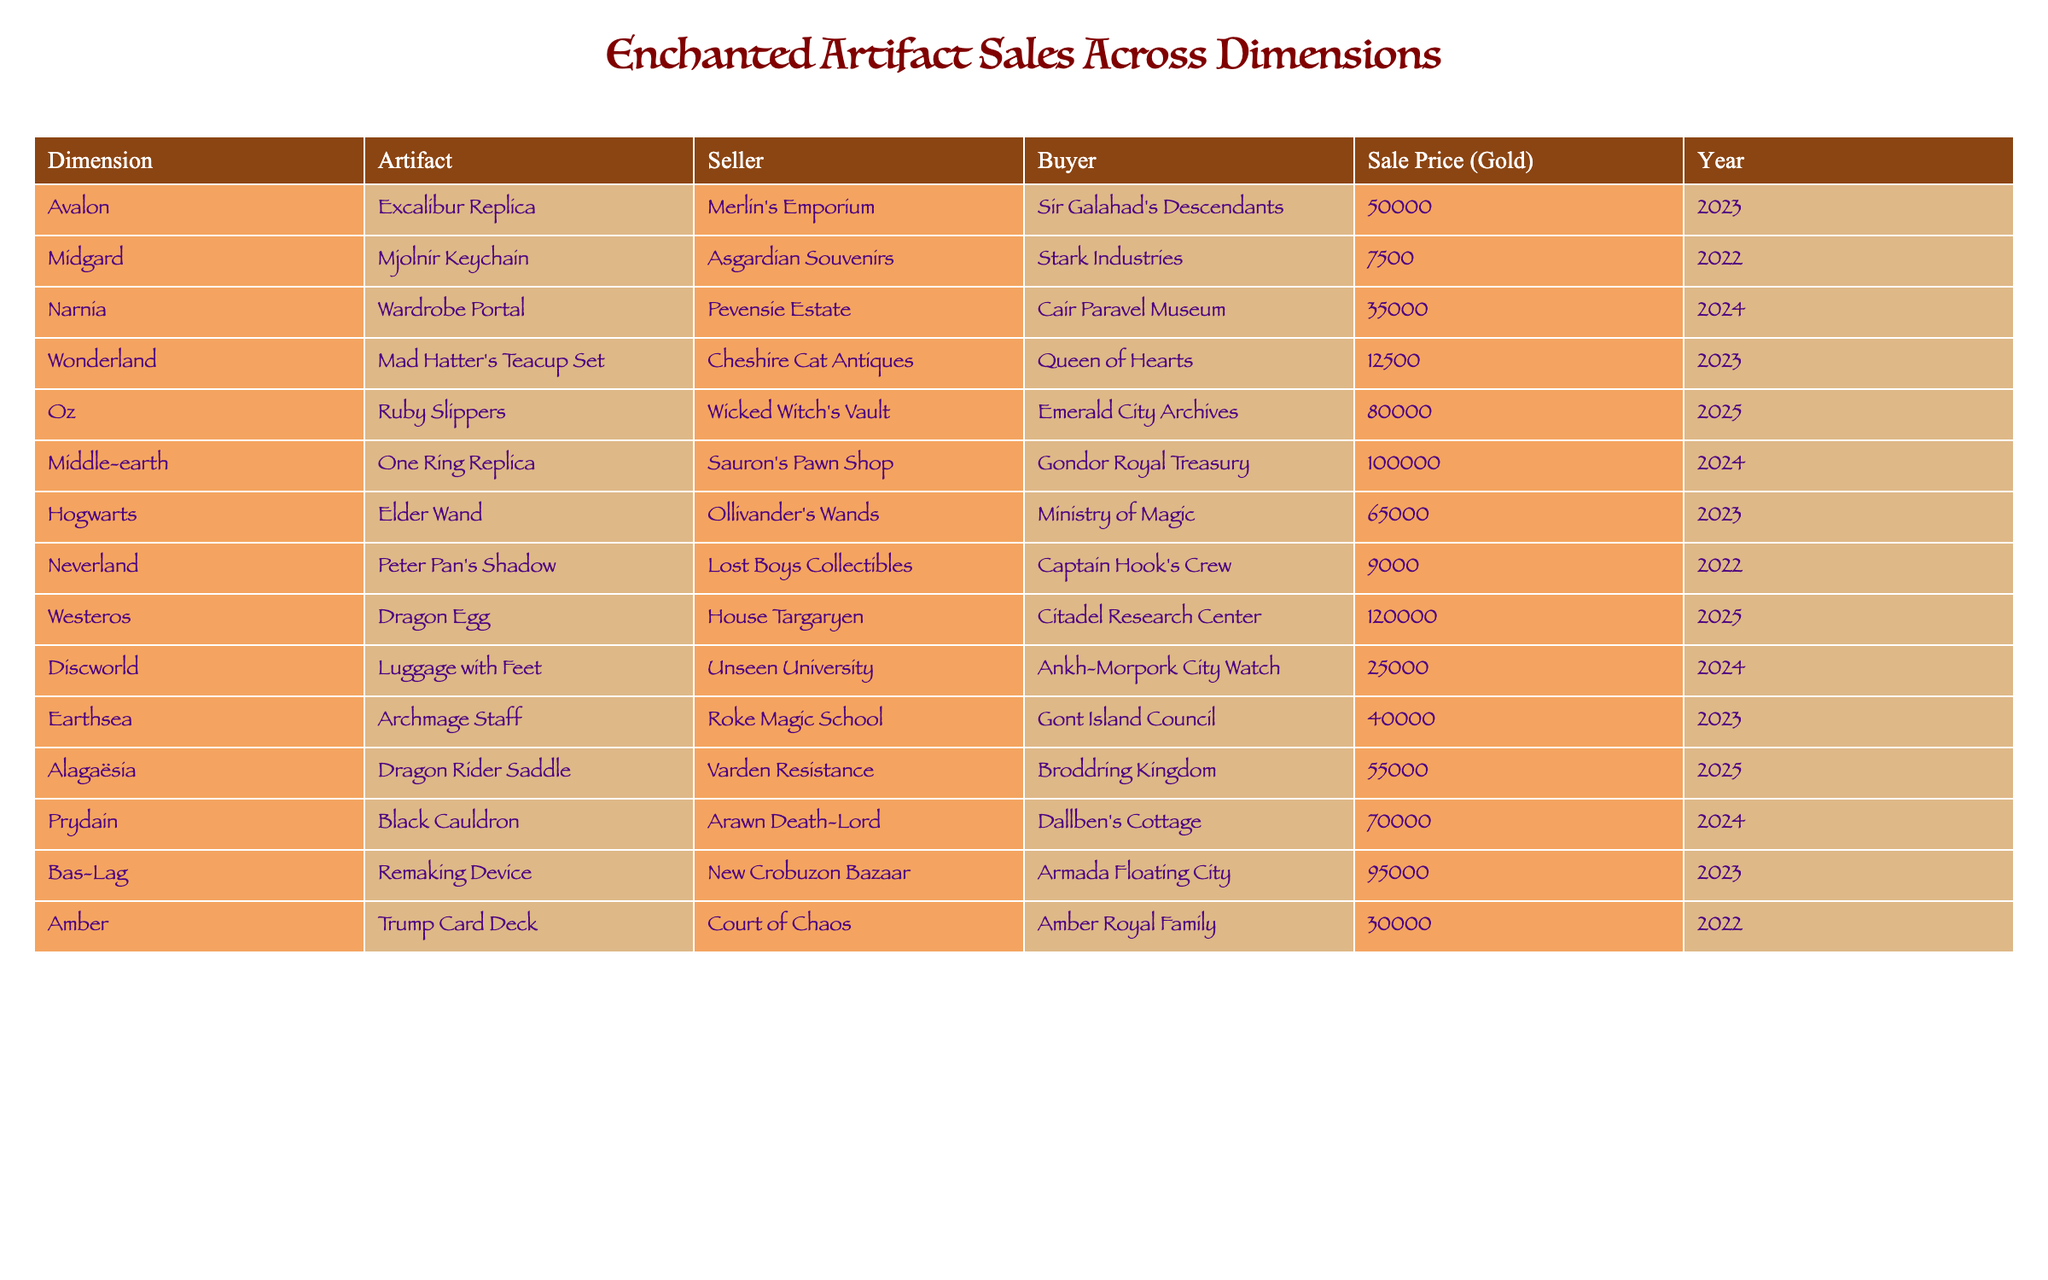What is the highest sale price for an enchanted artifact? By reviewing the "Sale Price (Gold)" column, the highest value listed is 120000, which corresponds to the Dragon Egg sold in Westeros.
Answer: 120000 Which artifact was sold by Ollivander's Wands? The table shows that the Elder Wand was sold by Ollivander's Wands.
Answer: Elder Wand What is the total sale price of artifacts sold in the year 2023? Adding the sale prices for 2023: 50000 (Excalibur Replica) + 12500 (Mad Hatter's Teacup Set) + 65000 (Elder Wand) + 40000 (Archmage Staff) + 95000 (Remaking Device) gives a total of 262500.
Answer: 262500 How many artifacts were sold for over 70000 gold? Checking the table, we find that the artifacts sold for over 70000 gold are: Ruby Slippers, One Ring Replica, Dragon Egg, Prydain's Black Cauldron, and the Remaking Device, totaling 5 items.
Answer: 5 Was the Mjolnir Keychain sold at a higher price than the Ruby Slippers? The sale price for the Mjolnir Keychain is 7500, while the Ruby Slippers sold for 80000. Since 7500 is less than 80000, the answer is no.
Answer: No Which dimension had the most expensive artifact sold in 2024? Looking at the 2024 entries, the One Ring Replica in Middle-earth was sold for 100000, which is more than the Wardrobe Portal's 35000 and the Alagaësia's Dragon Rider Saddle's 55000. Thus, Middle-earth had the most expensive artifact sold in 2024.
Answer: Middle-earth What is the average sale price of artifacts sold in Narnia and Wonderland? The sale prices in Narnia and Wonderland are 35000 for the Wardrobe Portal and 12500 for the Mad Hatter's Teacup Set. The average is (35000 + 12500) / 2 = 23750.
Answer: 23750 Which seller sold the highest number of artifacts? The table illustrates unique sales by each seller, with no duplicates; therefore, each seller only sold one artifact, meaning no seller has sold multiple artifacts.
Answer: None Are there any artifacts sold in 2022? Yes, both the Mjolnir Keychain and Peter Pan's Shadow were sold in 2022.
Answer: Yes What is the difference in sale price between the Excalibur Replica and the One Ring Replica? The Excalibur Replica sold for 50000, while the One Ring Replica sold for 100000. The difference is 100000 - 50000 = 50000.
Answer: 50000 